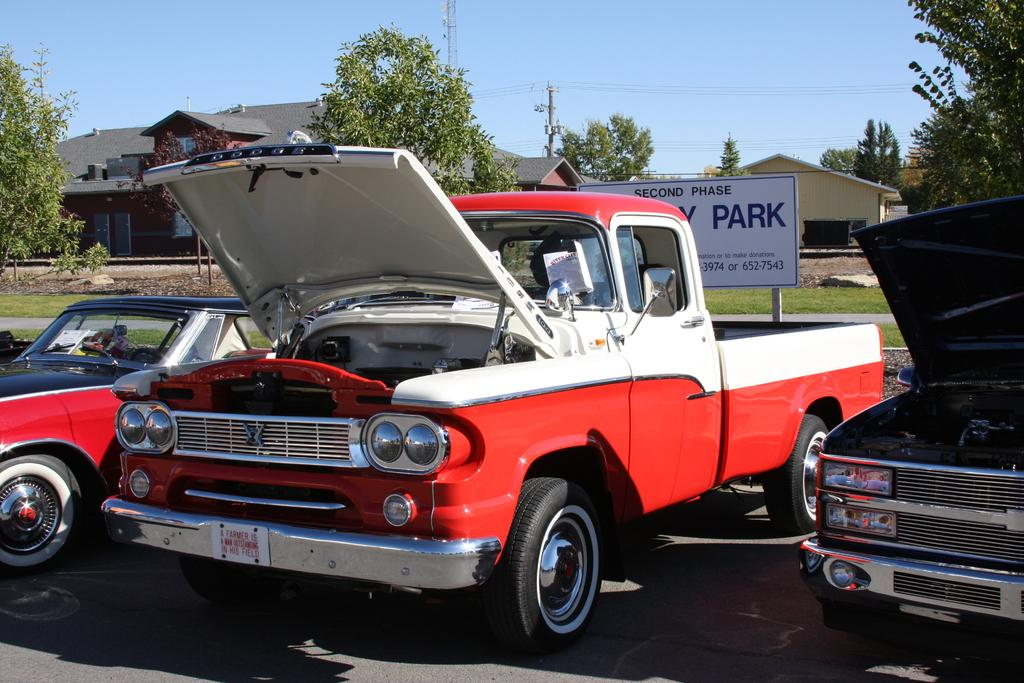What can be seen on the road in the image? There are vehicles on the road in the image. What is the board used for in the image? The purpose of the board in the image is not specified, but it could be a sign or advertisement. What is the pole supporting in the image? The pole in the image could be supporting a sign, traffic light, or other infrastructure. What type of vegetation is visible in the image? Grass is visible in the image. What can be seen in the background of the image? In the background of the image, there are trees, houses, and the sky. What type of meal is being prepared in the image? There is no meal preparation visible in the image; it primarily features vehicles on the road, a board, a pole, grass, trees, houses, and the sky. 